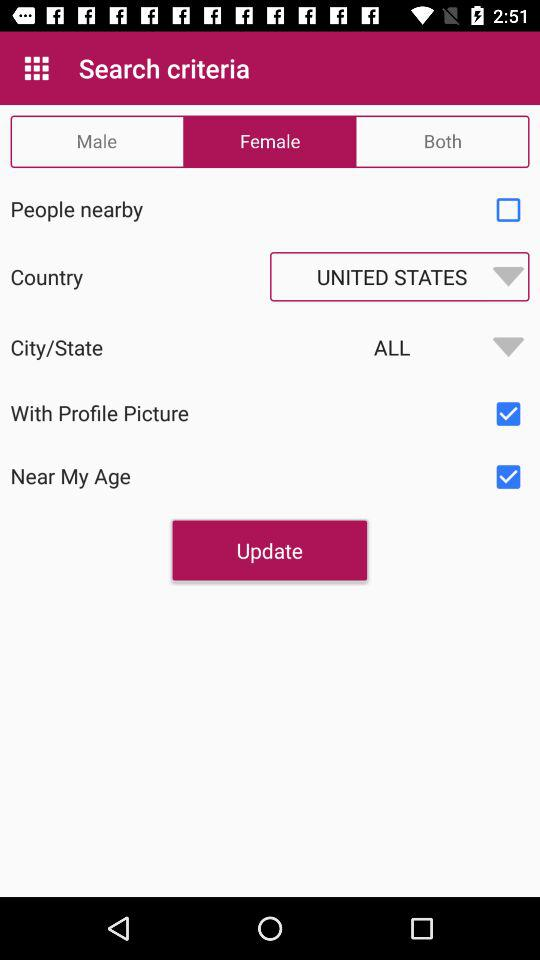What are the different search criteria? The search criteria are "Male", "Female" and "Both". 